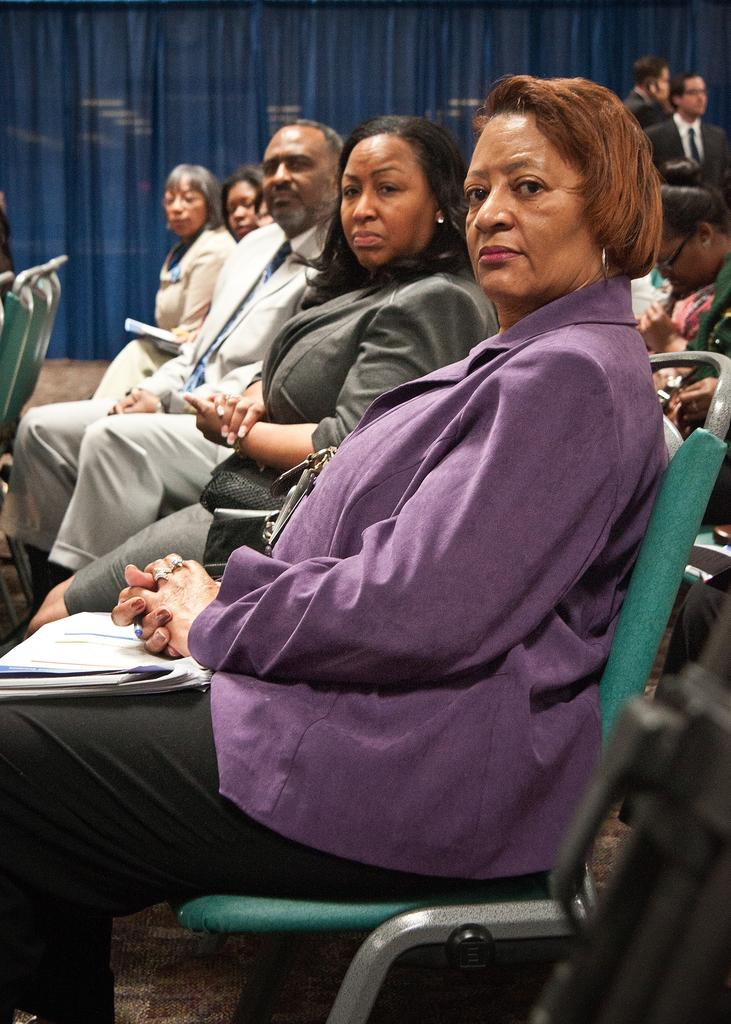What can be seen in the image in terms of seating arrangements? There are many chairs in the image. What are the people on the chairs doing? People are sitting on the chairs. What type of clothing are most of the people wearing? Most of the people are wearing blazers. Can you describe the gender distribution of the people in the image? There are both men and women in the image. What can be seen at the top of the image? There are curtains visible at the top of the image. How many stomachs does the squirrel have in the image? There is no squirrel present in the image, so it is not possible to determine the number of stomachs it might have. 